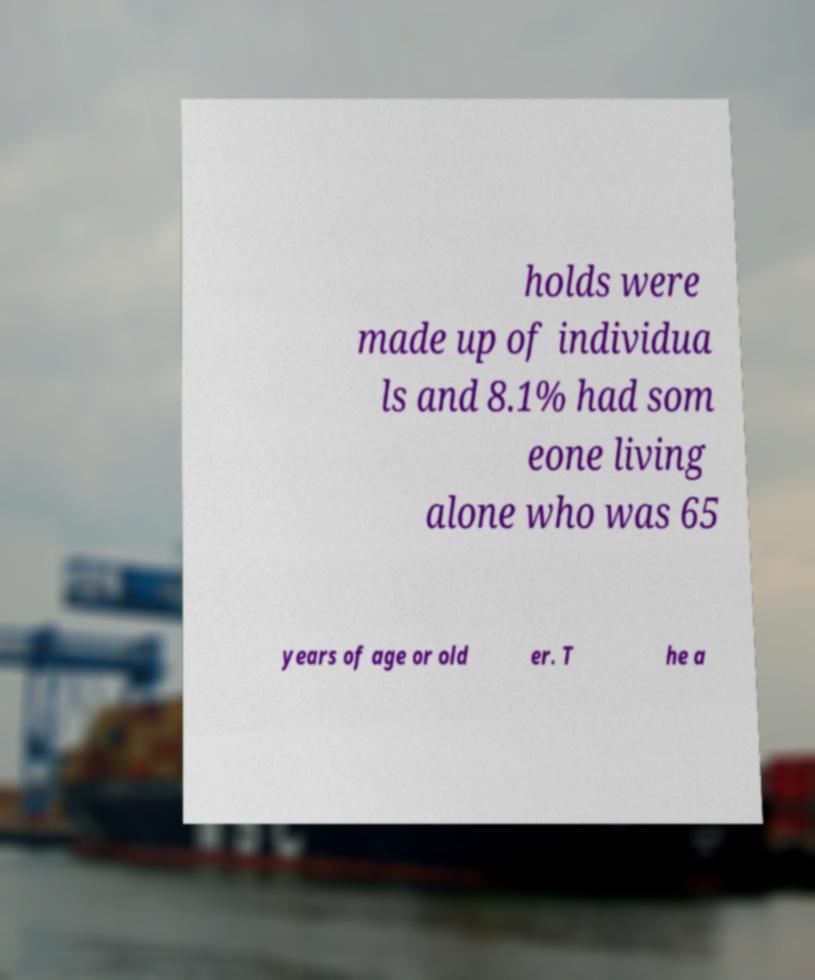What messages or text are displayed in this image? I need them in a readable, typed format. holds were made up of individua ls and 8.1% had som eone living alone who was 65 years of age or old er. T he a 